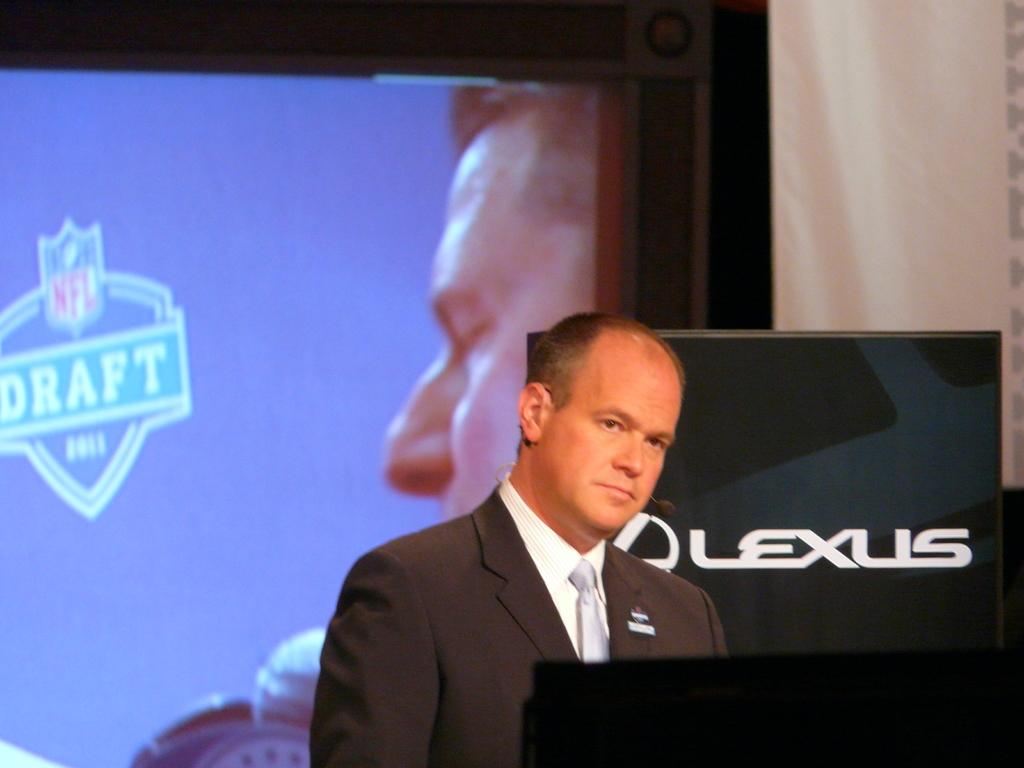What is the main subject in the middle of the image? There is a man in the middle of the image. What type of clothing is the man wearing? The man is wearing a coat, a tie, and a shirt. What can be seen on the left side of the image? There is a projector screen on the left side of the image. Can you see any beads on the man's tie in the image? There is no mention of beads on the man's tie in the provided facts, so we cannot determine if any are present. Is there a deer visible in the image? There is no mention of a deer in the provided facts, so we cannot determine if one is present. 